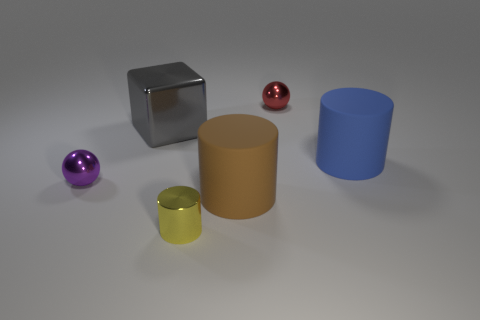What is the material of the tiny yellow cylinder? metal 